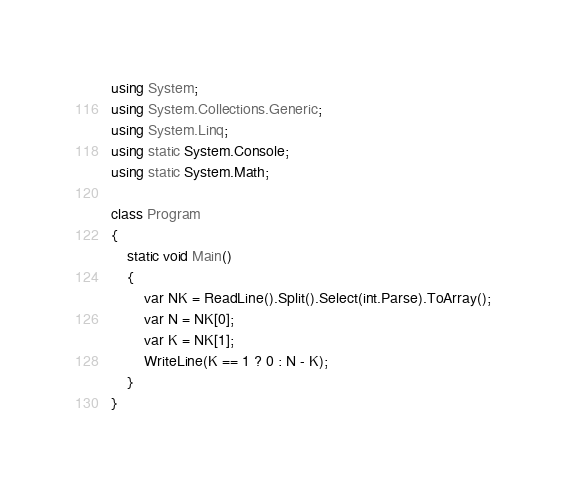<code> <loc_0><loc_0><loc_500><loc_500><_C#_>using System;
using System.Collections.Generic;
using System.Linq;
using static System.Console;
using static System.Math;

class Program
{
    static void Main()
    {
        var NK = ReadLine().Split().Select(int.Parse).ToArray();
        var N = NK[0];
        var K = NK[1];
        WriteLine(K == 1 ? 0 : N - K);
    }
}</code> 